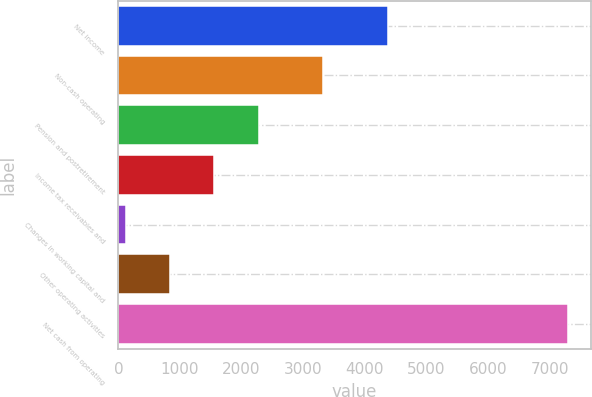<chart> <loc_0><loc_0><loc_500><loc_500><bar_chart><fcel>Net income<fcel>Non-cash operating<fcel>Pension and postretirement<fcel>Income tax receivables and<fcel>Changes in working capital and<fcel>Other operating activities<fcel>Net cash from operating<nl><fcel>4372<fcel>3318<fcel>2275.9<fcel>1557.6<fcel>121<fcel>839.3<fcel>7304<nl></chart> 